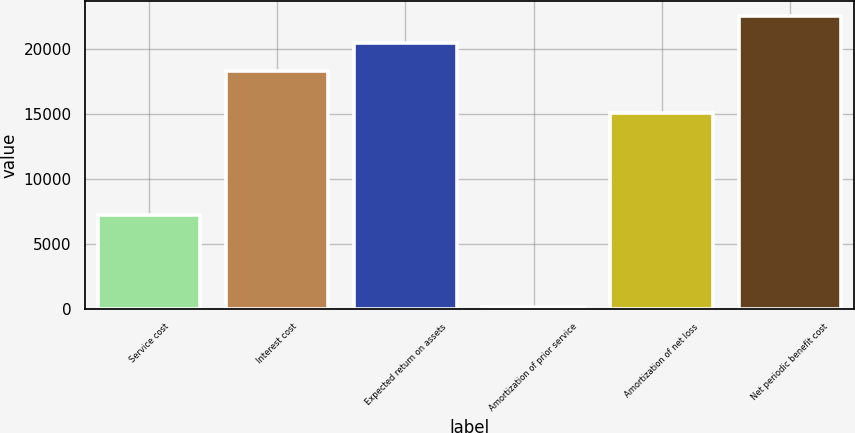Convert chart. <chart><loc_0><loc_0><loc_500><loc_500><bar_chart><fcel>Service cost<fcel>Interest cost<fcel>Expected return on assets<fcel>Amortization of prior service<fcel>Amortization of net loss<fcel>Net periodic benefit cost<nl><fcel>7238<fcel>18324<fcel>20435.4<fcel>193<fcel>15078<fcel>22546.8<nl></chart> 